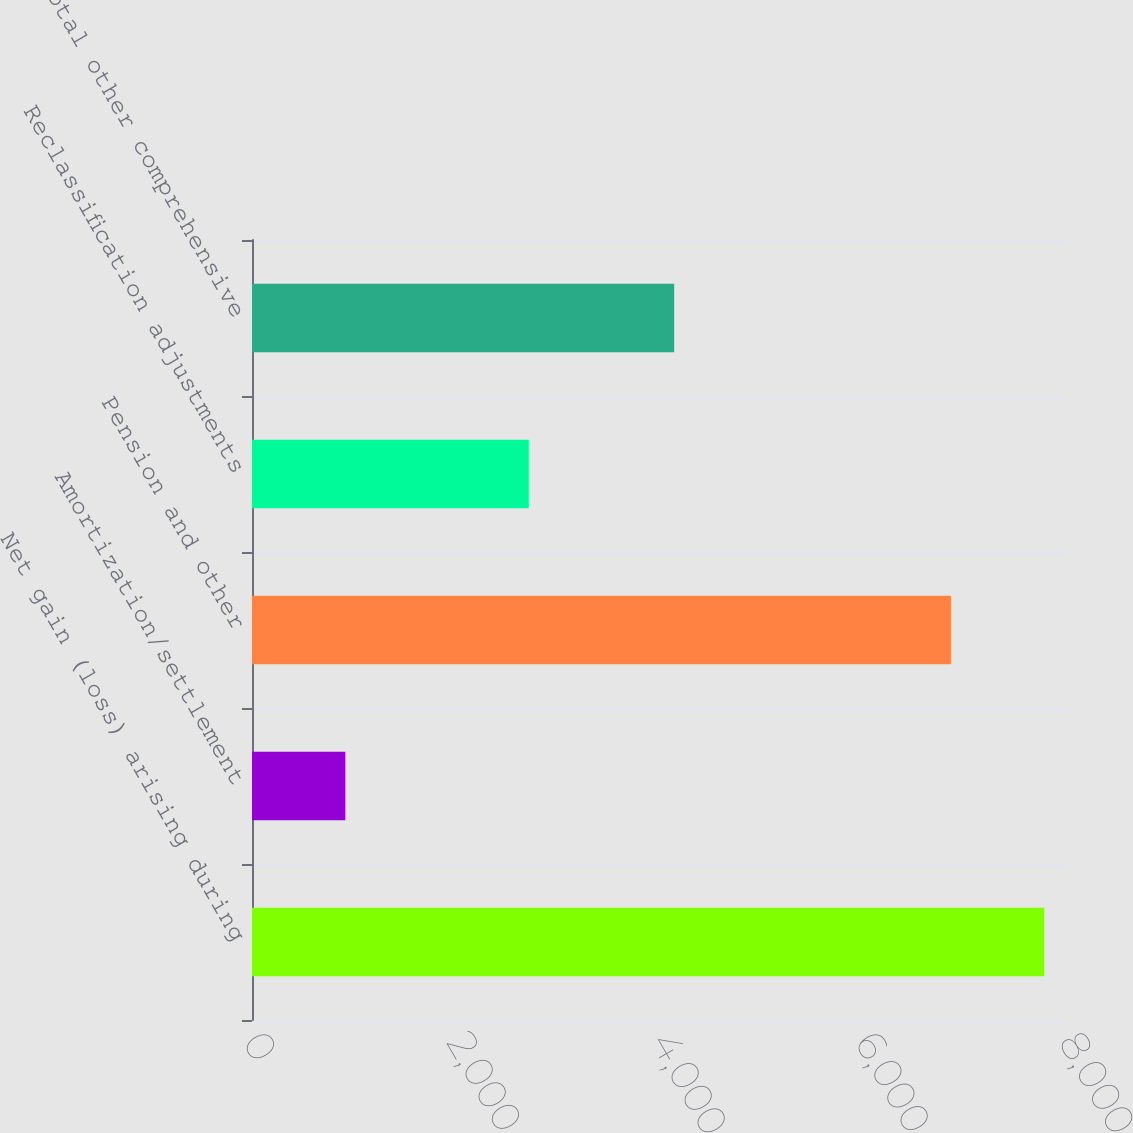Convert chart. <chart><loc_0><loc_0><loc_500><loc_500><bar_chart><fcel>Net gain (loss) arising during<fcel>Amortization/settlement<fcel>Pension and other<fcel>Reclassification adjustments<fcel>Total other comprehensive<nl><fcel>7767<fcel>915<fcel>6852<fcel>2713<fcel>4139<nl></chart> 